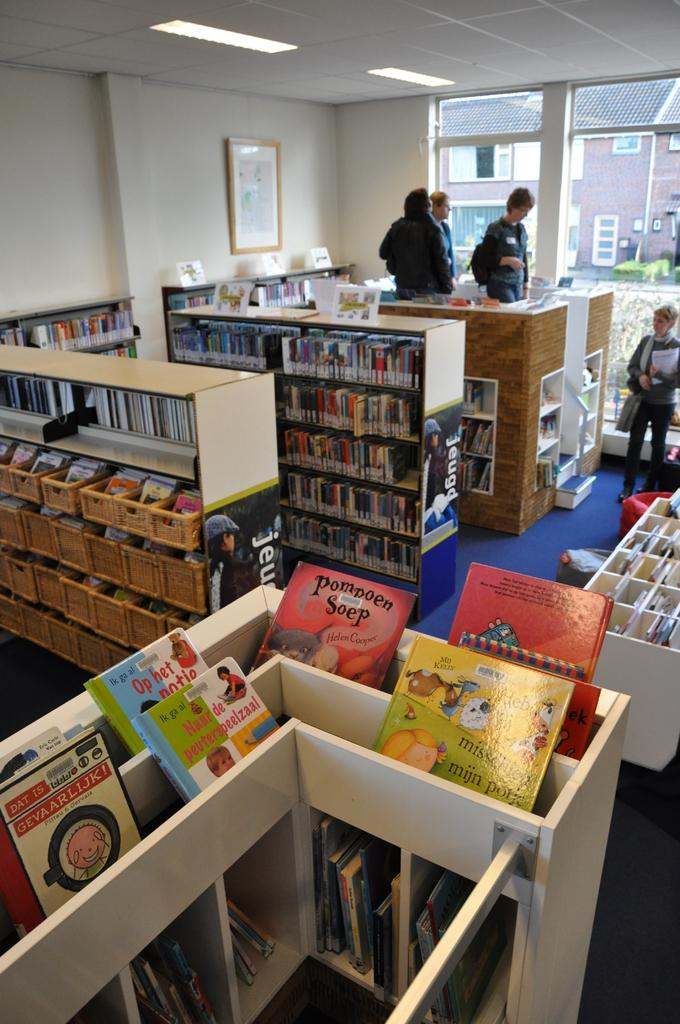Provide a one-sentence caption for the provided image. A room full of shelving and children's books with a picture with Jeug printed on the end of some units. 